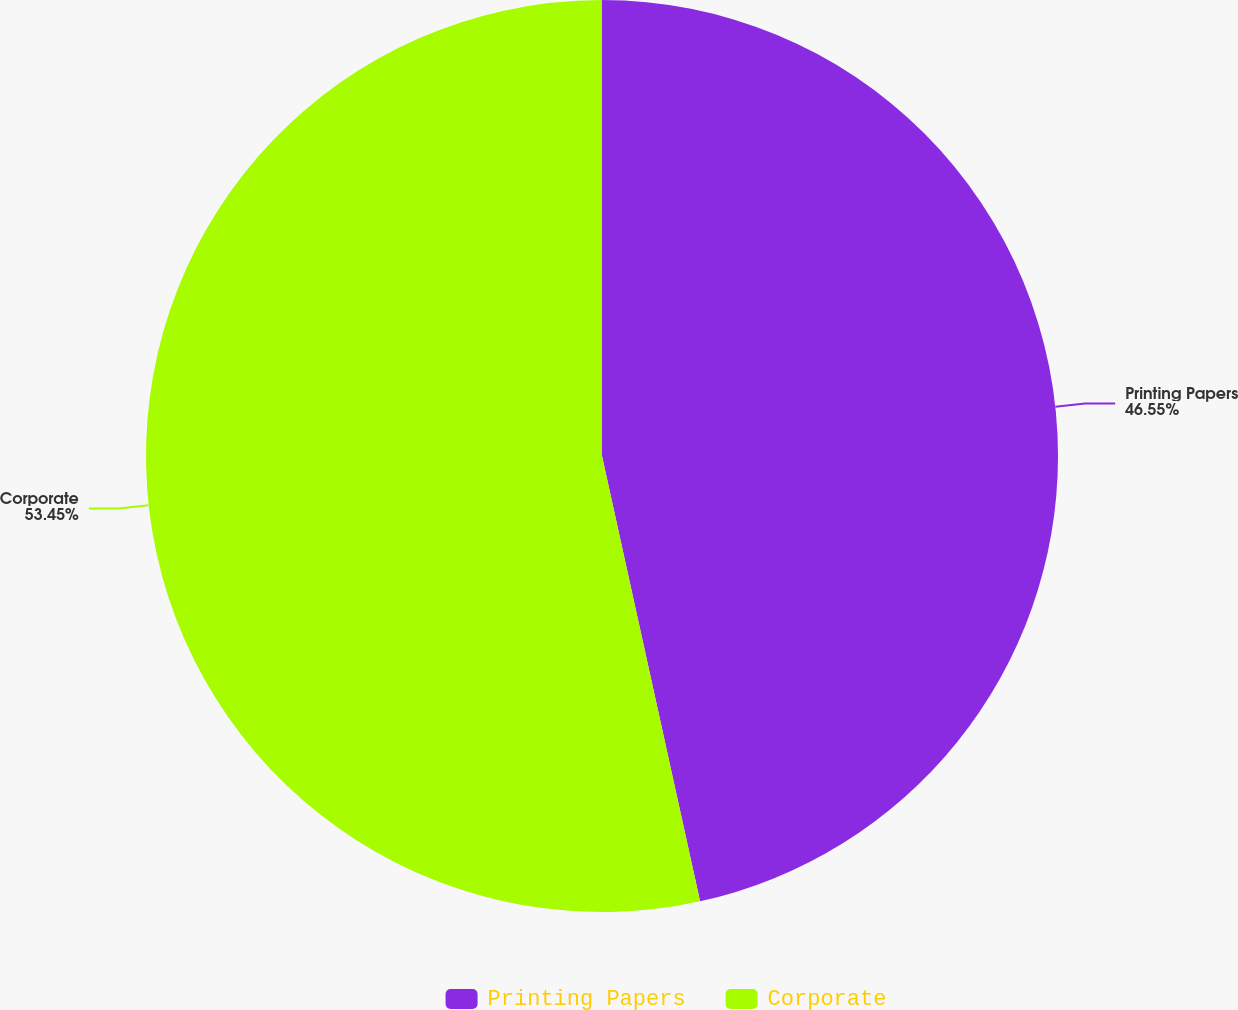Convert chart. <chart><loc_0><loc_0><loc_500><loc_500><pie_chart><fcel>Printing Papers<fcel>Corporate<nl><fcel>46.55%<fcel>53.45%<nl></chart> 